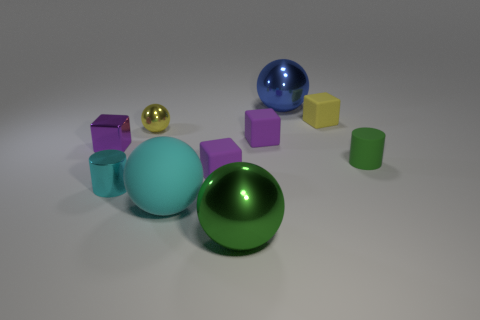Subtract all blue cylinders. How many purple cubes are left? 3 Subtract 1 balls. How many balls are left? 3 Subtract all spheres. How many objects are left? 6 Add 5 yellow things. How many yellow things are left? 7 Add 6 green rubber cylinders. How many green rubber cylinders exist? 7 Subtract 0 red cubes. How many objects are left? 10 Subtract all small yellow metal balls. Subtract all small purple metallic cubes. How many objects are left? 8 